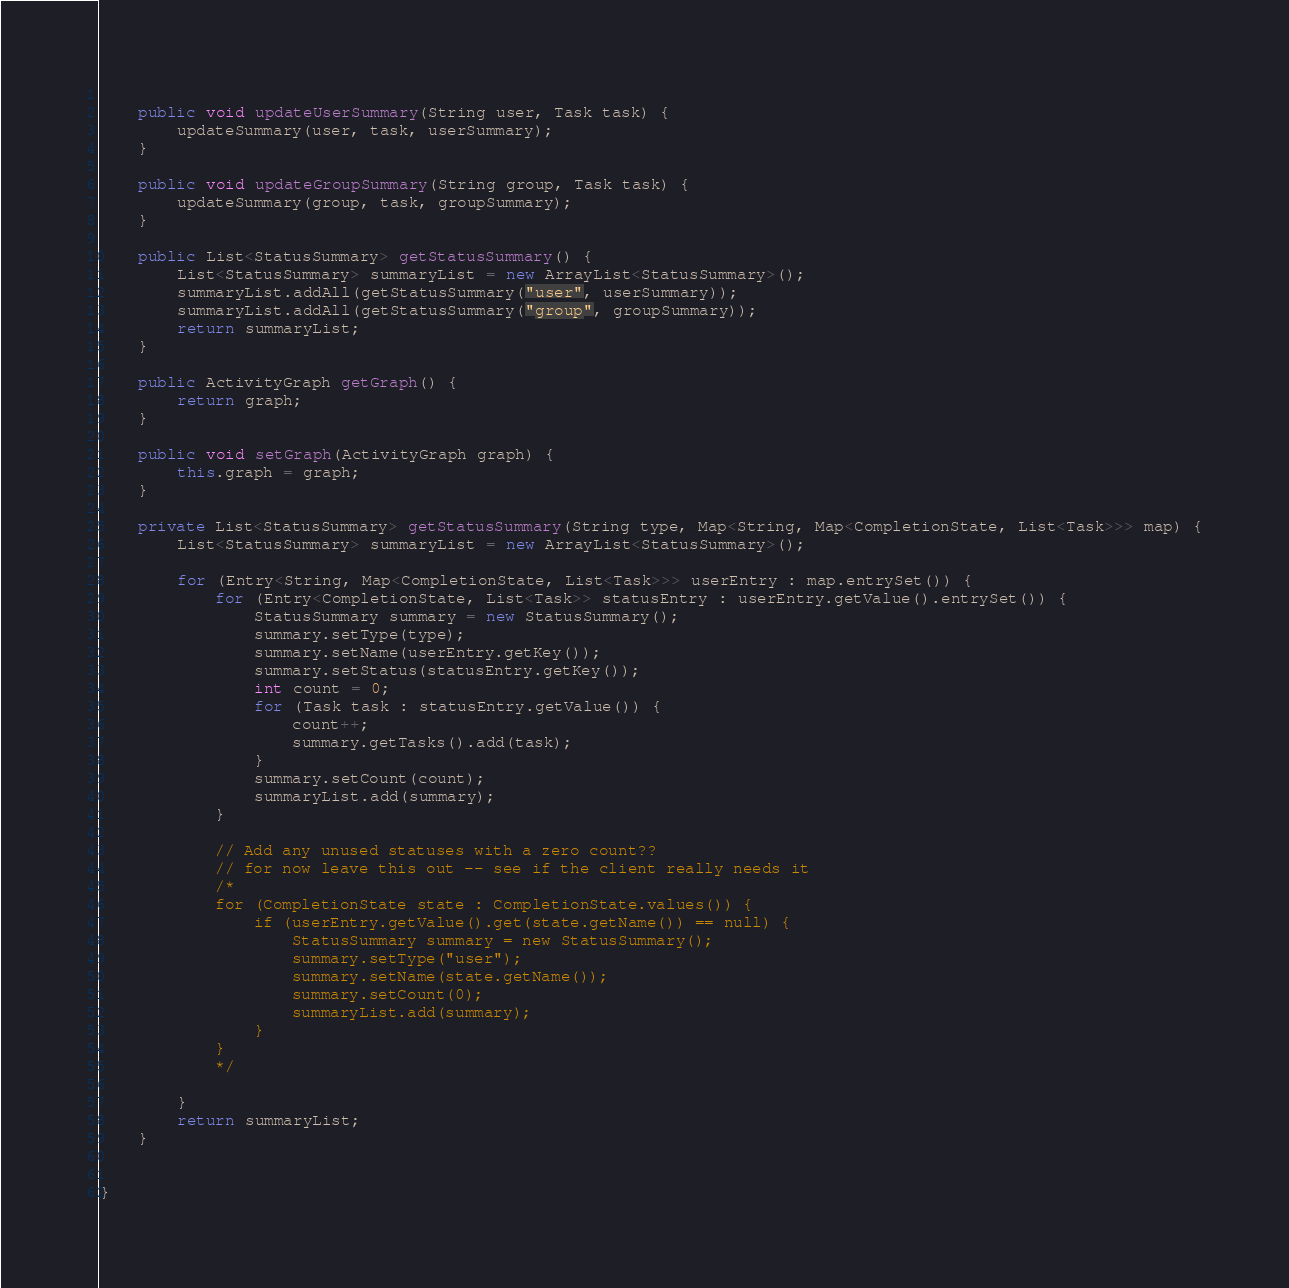Convert code to text. <code><loc_0><loc_0><loc_500><loc_500><_Java_>	
	public void updateUserSummary(String user, Task task) {
		updateSummary(user, task, userSummary);
	}
	
	public void updateGroupSummary(String group, Task task) {
		updateSummary(group, task, groupSummary);
	}
	
	public List<StatusSummary> getStatusSummary() {
		List<StatusSummary> summaryList = new ArrayList<StatusSummary>();
		summaryList.addAll(getStatusSummary("user", userSummary));
		summaryList.addAll(getStatusSummary("group", groupSummary));
		return summaryList;
	}
	
	public ActivityGraph getGraph() {
		return graph;
	}

	public void setGraph(ActivityGraph graph) {
		this.graph = graph;
	}

	private List<StatusSummary> getStatusSummary(String type, Map<String, Map<CompletionState, List<Task>>> map) {
		List<StatusSummary> summaryList = new ArrayList<StatusSummary>();
		
		for (Entry<String, Map<CompletionState, List<Task>>> userEntry : map.entrySet()) {
			for (Entry<CompletionState, List<Task>> statusEntry : userEntry.getValue().entrySet()) {
				StatusSummary summary = new StatusSummary();
				summary.setType(type);
				summary.setName(userEntry.getKey());
				summary.setStatus(statusEntry.getKey());
				int count = 0;
				for (Task task : statusEntry.getValue()) {
					count++;
					summary.getTasks().add(task);	
				}
				summary.setCount(count);
				summaryList.add(summary);
			}
			
			// Add any unused statuses with a zero count??
			// for now leave this out -- see if the client really needs it
			/*
			for (CompletionState state : CompletionState.values()) {
				if (userEntry.getValue().get(state.getName()) == null) {
					StatusSummary summary = new StatusSummary();
					summary.setType("user");
					summary.setName(state.getName());
					summary.setCount(0);
					summaryList.add(summary);
				}
			}
			*/
			
		}
		return summaryList;	
	}
      

}
</code> 